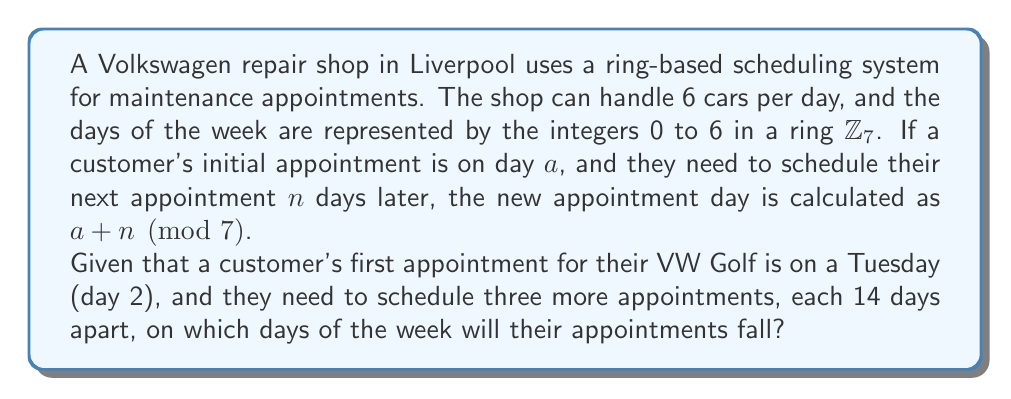Give your solution to this math problem. Let's approach this step-by-step using ring theory:

1) We're working in the ring $\mathbb{Z}_7$, where the days of the week are represented as:
   Sunday = 0, Monday = 1, Tuesday = 2, Wednesday = 3, Thursday = 4, Friday = 5, Saturday = 6

2) The first appointment is on Tuesday, so $a = 2$.

3) Each subsequent appointment is 14 days later. In $\mathbb{Z}_7$, this is equivalent to adding 0, because:
   $14 \equiv 0 \pmod{7}$ (14 divided by 7 leaves a remainder of 0)

4) Let's calculate each appointment day:
   - 1st appointment: $2 + 0 \equiv 2 \pmod{7}$ (Tuesday)
   - 2nd appointment: $2 + 0 \equiv 2 \pmod{7}$ (Tuesday)
   - 3rd appointment: $2 + 0 \equiv 2 \pmod{7}$ (Tuesday)
   - 4th appointment: $2 + 0 \equiv 2 \pmod{7}$ (Tuesday)

5) We can verify this intuitively: 14 days is exactly 2 weeks, so each appointment will fall on the same day of the week as the initial appointment.

This ring-based system allows the shop to easily schedule recurring appointments without needing to manually count days or use complex calendars.
Answer: All four appointments will fall on Tuesdays. 